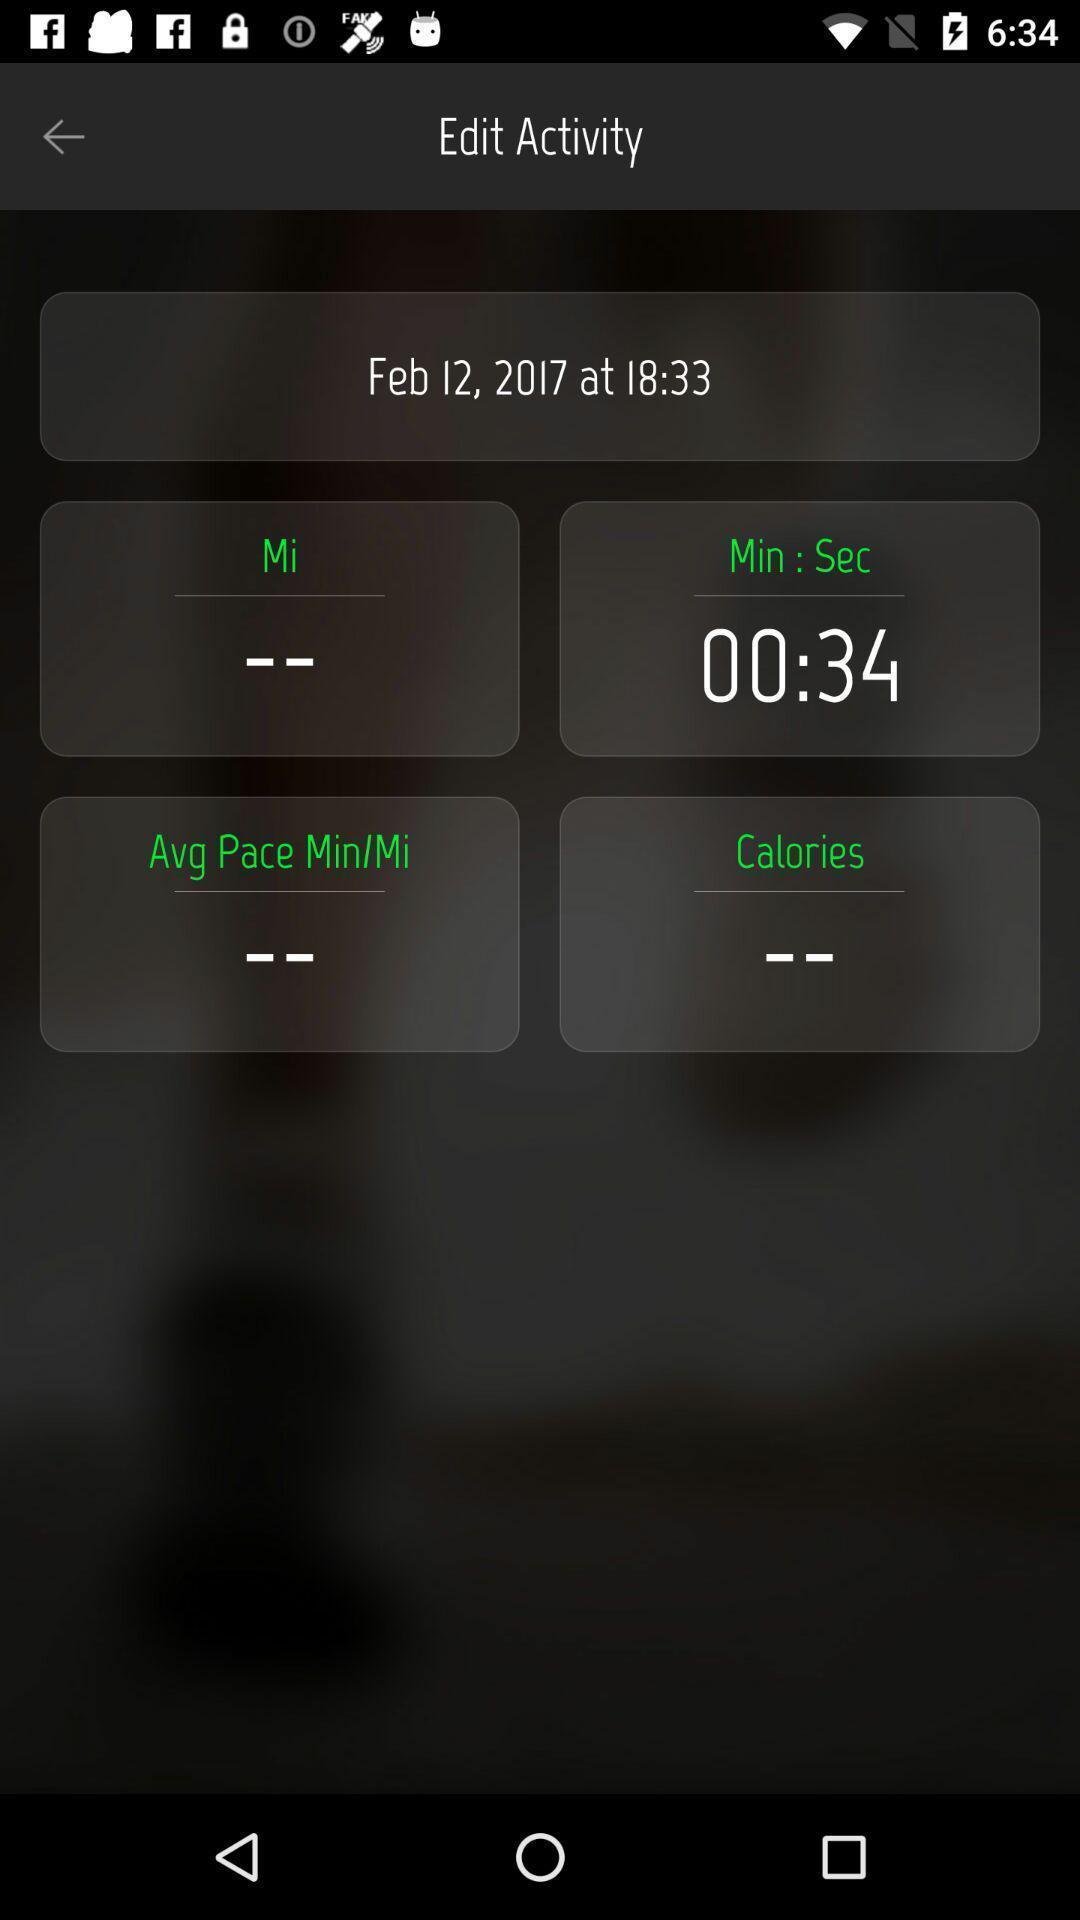Explain what's happening in this screen capture. Page displaying the details about time tracking. 